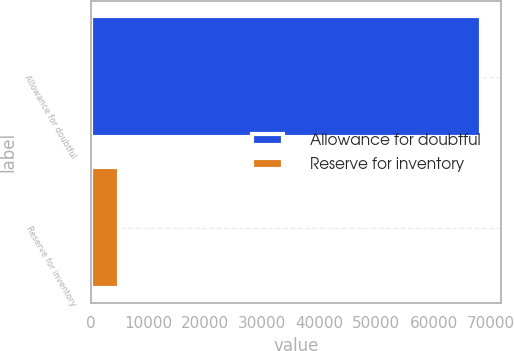Convert chart. <chart><loc_0><loc_0><loc_500><loc_500><bar_chart><fcel>Allowance for doubtful<fcel>Reserve for inventory<nl><fcel>68330<fcel>4900<nl></chart> 